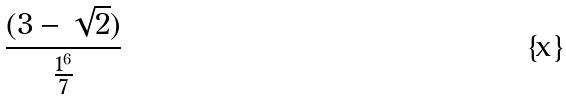Convert formula to latex. <formula><loc_0><loc_0><loc_500><loc_500>\frac { ( 3 - \sqrt { 2 } ) } { \frac { 1 ^ { 6 } } { 7 } }</formula> 